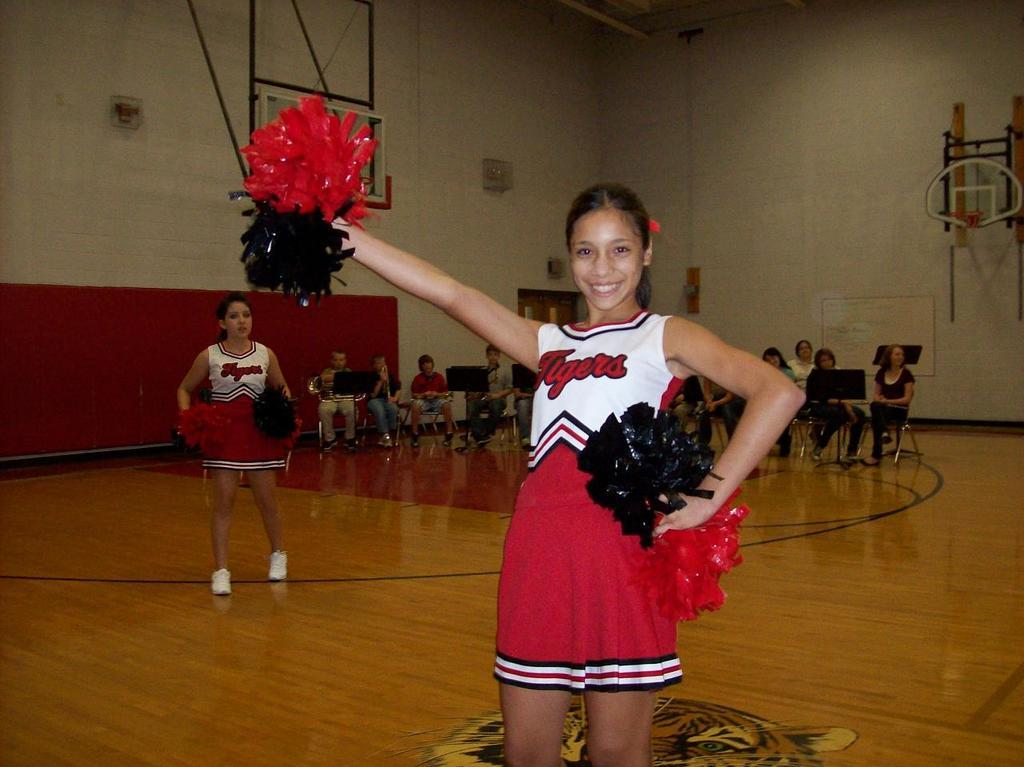Provide a one-sentence caption for the provided image. Tigers cheerleaders practice in their red, black, and white uniforms. 